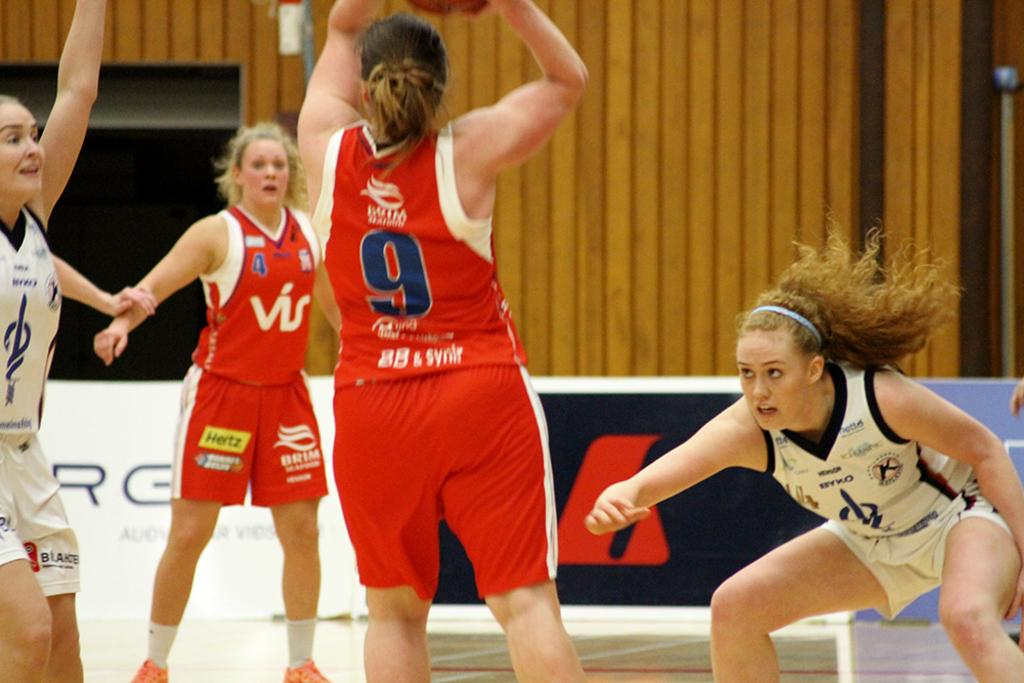<image>
Present a compact description of the photo's key features. the number 9 is on the back of a girl's jersey 